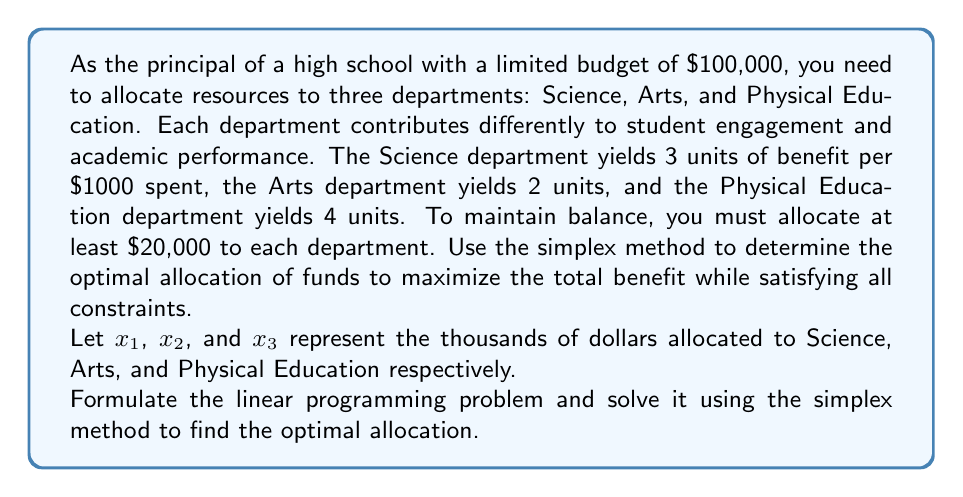Help me with this question. Let's approach this problem step-by-step using the simplex method:

1) Formulate the linear programming problem:

   Maximize: $Z = 3x_1 + 2x_2 + 4x_3$
   Subject to:
   $x_1 + x_2 + x_3 \leq 100$ (budget constraint)
   $x_1 \geq 20$, $x_2 \geq 20$, $x_3 \geq 20$ (minimum allocation constraints)
   $x_1, x_2, x_3 \geq 0$ (non-negativity constraints)

2) Convert to standard form by introducing slack variables:

   Maximize: $Z = 3x_1 + 2x_2 + 4x_3 + 0s_1 + 0s_2 + 0s_3 + 0s_4$
   Subject to:
   $x_1 + x_2 + x_3 + s_1 = 100$
   $x_1 - s_2 = 20$
   $x_2 - s_3 = 20$
   $x_3 - s_4 = 20$
   All variables $\geq 0$

3) Set up the initial simplex tableau:

   $$
   \begin{array}{c|cccccccc|c}
   & x_1 & x_2 & x_3 & s_1 & s_2 & s_3 & s_4 & Z & RHS \\
   \hline
   s_1 & 1 & 1 & 1 & 1 & 0 & 0 & 0 & 0 & 100 \\
   s_2 & 1 & 0 & 0 & 0 & -1 & 0 & 0 & 0 & 20 \\
   s_3 & 0 & 1 & 0 & 0 & 0 & -1 & 0 & 0 & 20 \\
   s_4 & 0 & 0 & 1 & 0 & 0 & 0 & -1 & 0 & 20 \\
   \hline
   Z & -3 & -2 & -4 & 0 & 0 & 0 & 0 & 1 & 0 \\
   \end{array}
   $$

4) Identify the pivot column (most negative in Z row): $x_3$

5) Calculate the ratios and identify the pivot row:
   $100/1 = 100$, $20/0 = \infty$, $20/0 = \infty$, $20/1 = 20$
   Pivot row is the last row (smallest ratio)

6) Perform row operations to get the new tableau:

   $$
   \begin{array}{c|cccccccc|c}
   & x_1 & x_2 & x_3 & s_1 & s_2 & s_3 & s_4 & Z & RHS \\
   \hline
   s_1 & 1 & 1 & 0 & 1 & 0 & 0 & 1 & 0 & 80 \\
   s_2 & 1 & 0 & 0 & 0 & -1 & 0 & 0 & 0 & 20 \\
   s_3 & 0 & 1 & 0 & 0 & 0 & -1 & 0 & 0 & 20 \\
   x_3 & 0 & 0 & 1 & 0 & 0 & 0 & -1 & 0 & 20 \\
   \hline
   Z & -3 & -2 & 0 & 0 & 0 & 0 & 4 & 1 & 80 \\
   \end{array}
   $$

7) Repeat steps 4-6 until no negative values remain in the Z row.

8) Final optimal tableau:

   $$
   \begin{array}{c|cccccccc|c}
   & x_1 & x_2 & x_3 & s_1 & s_2 & s_3 & s_4 & Z & RHS \\
   \hline
   x_1 & 1 & 0 & 0 & 1 & 0 & 1 & 0 & 0 & 60 \\
   x_2 & 0 & 1 & 0 & 0 & 0 & -1 & 0 & 0 & 20 \\
   x_3 & 0 & 0 & 1 & 0 & 0 & 0 & -1 & 0 & 20 \\
   s_2 & 0 & 0 & 0 & -1 & -1 & -1 & 0 & 0 & -40 \\
   \hline
   Z & 0 & 0 & 0 & 3 & 0 & 1 & 4 & 1 & 260 \\
   \end{array}
   $$

9) Read the optimal solution from the final tableau:
   $x_1 = 60$, $x_2 = 20$, $x_3 = 20$
   Maximum Z = 260
Answer: The optimal allocation of funds is:
Science department: $60,000
Arts department: $20,000
Physical Education department: $20,000
This allocation yields a maximum benefit of 260 units. 